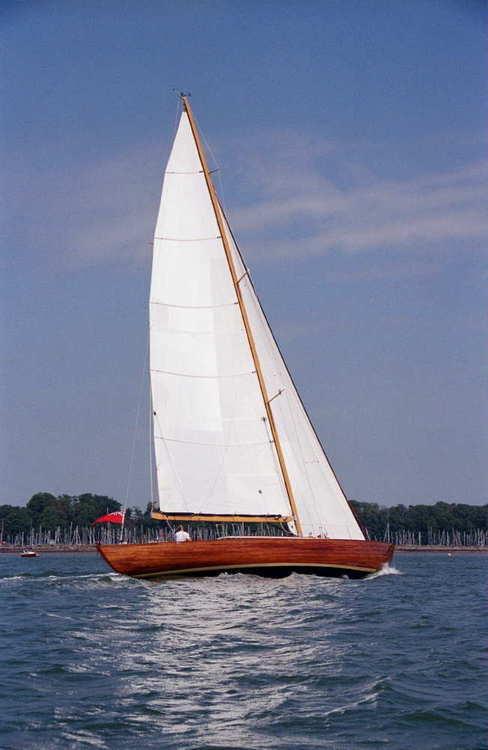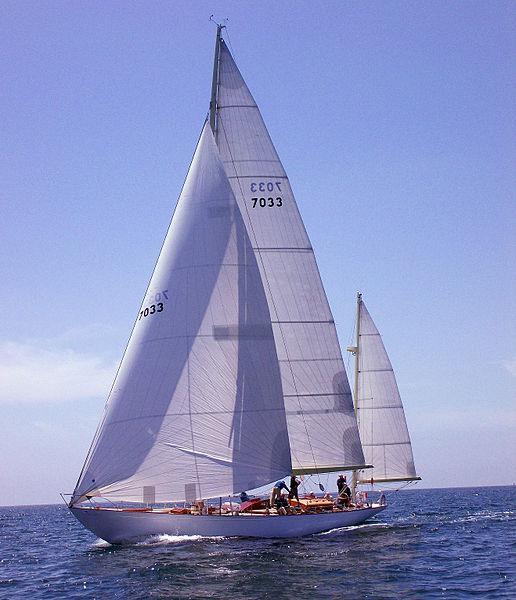The first image is the image on the left, the second image is the image on the right. For the images shown, is this caption "The sky in the image on the right is cloudless." true? Answer yes or no. No. 